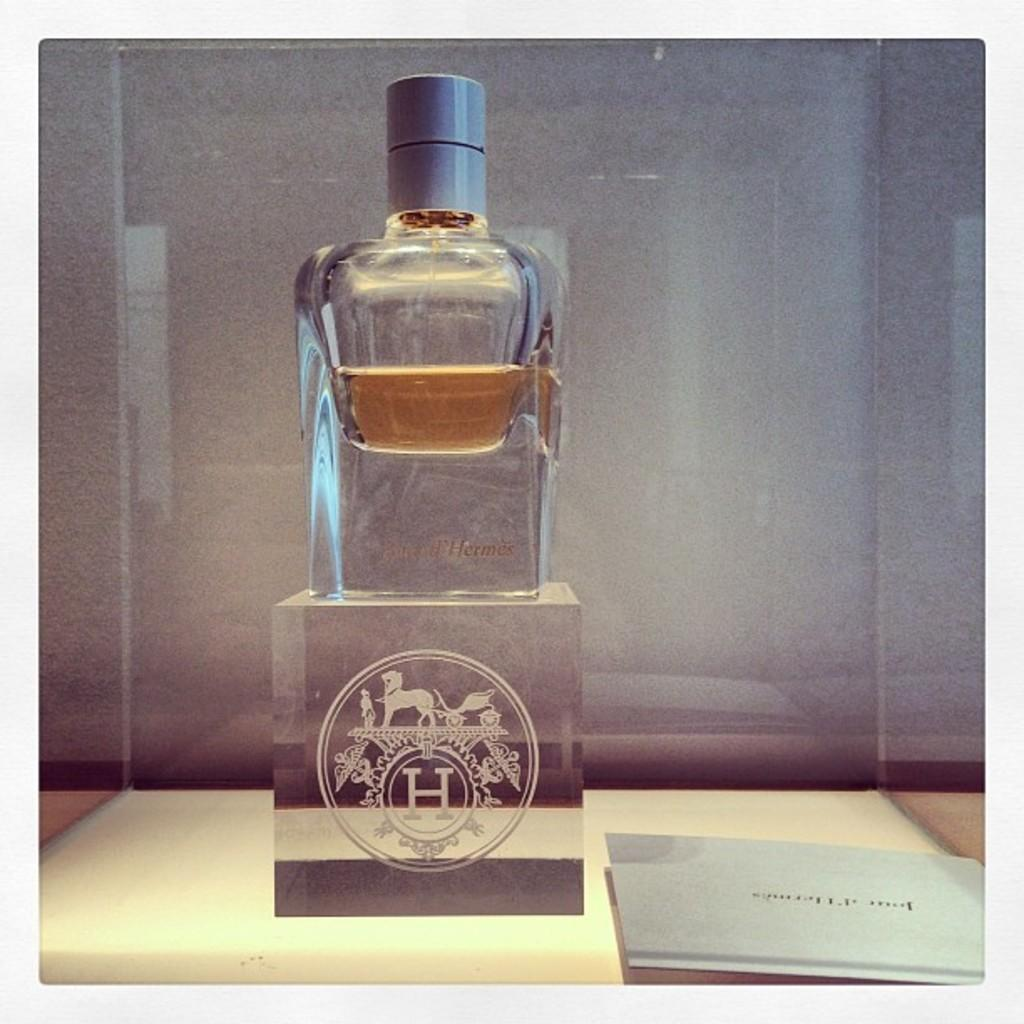<image>
Render a clear and concise summary of the photo. A bottle sits on a glass base etched with the letter H. 